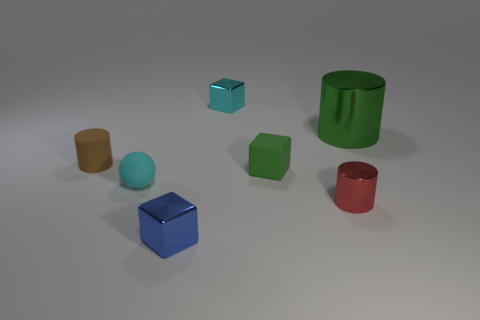Add 2 large yellow cylinders. How many objects exist? 9 Subtract all spheres. How many objects are left? 6 Add 4 green cubes. How many green cubes exist? 5 Subtract 0 purple spheres. How many objects are left? 7 Subtract all large shiny blocks. Subtract all large green cylinders. How many objects are left? 6 Add 4 metal cubes. How many metal cubes are left? 6 